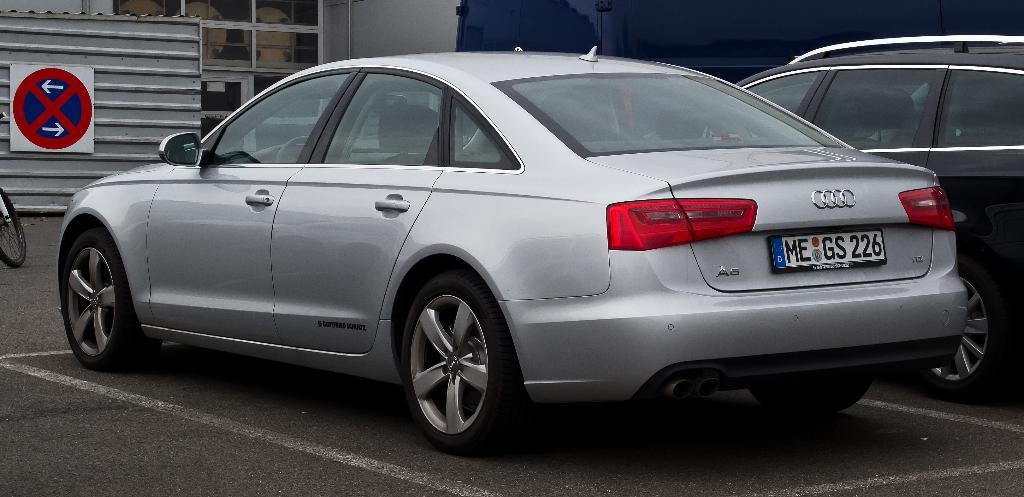<image>
Offer a succinct explanation of the picture presented. A parked car with the license plate number MEGS226. 